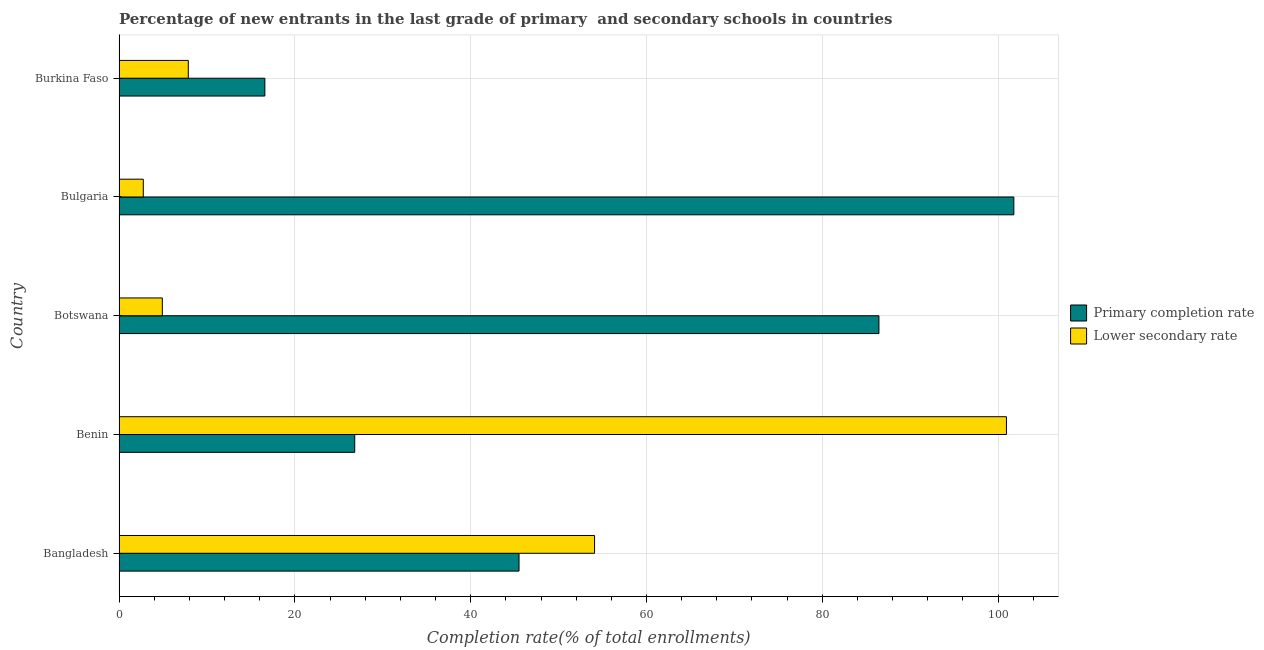How many different coloured bars are there?
Offer a terse response. 2. How many groups of bars are there?
Keep it short and to the point. 5. How many bars are there on the 2nd tick from the bottom?
Provide a succinct answer. 2. What is the completion rate in secondary schools in Botswana?
Offer a terse response. 4.92. Across all countries, what is the maximum completion rate in secondary schools?
Your response must be concise. 100.95. Across all countries, what is the minimum completion rate in primary schools?
Offer a terse response. 16.59. In which country was the completion rate in primary schools maximum?
Ensure brevity in your answer.  Bulgaria. In which country was the completion rate in secondary schools minimum?
Your answer should be very brief. Bulgaria. What is the total completion rate in secondary schools in the graph?
Give a very brief answer. 170.6. What is the difference between the completion rate in secondary schools in Benin and that in Bulgaria?
Provide a short and direct response. 98.19. What is the difference between the completion rate in primary schools in Botswana and the completion rate in secondary schools in Burkina Faso?
Offer a terse response. 78.57. What is the average completion rate in secondary schools per country?
Your response must be concise. 34.12. What is the difference between the completion rate in primary schools and completion rate in secondary schools in Botswana?
Give a very brief answer. 81.52. What is the ratio of the completion rate in primary schools in Bangladesh to that in Bulgaria?
Ensure brevity in your answer.  0.45. Is the completion rate in primary schools in Bangladesh less than that in Benin?
Provide a succinct answer. No. Is the difference between the completion rate in secondary schools in Bangladesh and Botswana greater than the difference between the completion rate in primary schools in Bangladesh and Botswana?
Offer a terse response. Yes. What is the difference between the highest and the second highest completion rate in primary schools?
Offer a terse response. 15.35. What is the difference between the highest and the lowest completion rate in secondary schools?
Ensure brevity in your answer.  98.19. Is the sum of the completion rate in primary schools in Bangladesh and Benin greater than the maximum completion rate in secondary schools across all countries?
Make the answer very short. No. What does the 2nd bar from the top in Botswana represents?
Offer a terse response. Primary completion rate. What does the 1st bar from the bottom in Bangladesh represents?
Your response must be concise. Primary completion rate. Are all the bars in the graph horizontal?
Offer a terse response. Yes. What is the difference between two consecutive major ticks on the X-axis?
Make the answer very short. 20. Are the values on the major ticks of X-axis written in scientific E-notation?
Offer a very short reply. No. Does the graph contain grids?
Provide a succinct answer. Yes. How many legend labels are there?
Keep it short and to the point. 2. How are the legend labels stacked?
Provide a succinct answer. Vertical. What is the title of the graph?
Your response must be concise. Percentage of new entrants in the last grade of primary  and secondary schools in countries. Does "Imports" appear as one of the legend labels in the graph?
Ensure brevity in your answer.  No. What is the label or title of the X-axis?
Your response must be concise. Completion rate(% of total enrollments). What is the label or title of the Y-axis?
Keep it short and to the point. Country. What is the Completion rate(% of total enrollments) of Primary completion rate in Bangladesh?
Give a very brief answer. 45.5. What is the Completion rate(% of total enrollments) in Lower secondary rate in Bangladesh?
Ensure brevity in your answer.  54.09. What is the Completion rate(% of total enrollments) of Primary completion rate in Benin?
Make the answer very short. 26.81. What is the Completion rate(% of total enrollments) of Lower secondary rate in Benin?
Give a very brief answer. 100.95. What is the Completion rate(% of total enrollments) of Primary completion rate in Botswana?
Provide a succinct answer. 86.44. What is the Completion rate(% of total enrollments) in Lower secondary rate in Botswana?
Provide a succinct answer. 4.92. What is the Completion rate(% of total enrollments) in Primary completion rate in Bulgaria?
Provide a short and direct response. 101.79. What is the Completion rate(% of total enrollments) in Lower secondary rate in Bulgaria?
Make the answer very short. 2.76. What is the Completion rate(% of total enrollments) in Primary completion rate in Burkina Faso?
Offer a terse response. 16.59. What is the Completion rate(% of total enrollments) of Lower secondary rate in Burkina Faso?
Make the answer very short. 7.88. Across all countries, what is the maximum Completion rate(% of total enrollments) of Primary completion rate?
Your answer should be compact. 101.79. Across all countries, what is the maximum Completion rate(% of total enrollments) in Lower secondary rate?
Your response must be concise. 100.95. Across all countries, what is the minimum Completion rate(% of total enrollments) in Primary completion rate?
Offer a very short reply. 16.59. Across all countries, what is the minimum Completion rate(% of total enrollments) of Lower secondary rate?
Give a very brief answer. 2.76. What is the total Completion rate(% of total enrollments) of Primary completion rate in the graph?
Provide a succinct answer. 277.13. What is the total Completion rate(% of total enrollments) in Lower secondary rate in the graph?
Give a very brief answer. 170.6. What is the difference between the Completion rate(% of total enrollments) of Primary completion rate in Bangladesh and that in Benin?
Provide a short and direct response. 18.69. What is the difference between the Completion rate(% of total enrollments) in Lower secondary rate in Bangladesh and that in Benin?
Provide a short and direct response. -46.85. What is the difference between the Completion rate(% of total enrollments) in Primary completion rate in Bangladesh and that in Botswana?
Offer a very short reply. -40.94. What is the difference between the Completion rate(% of total enrollments) of Lower secondary rate in Bangladesh and that in Botswana?
Your answer should be compact. 49.17. What is the difference between the Completion rate(% of total enrollments) of Primary completion rate in Bangladesh and that in Bulgaria?
Offer a very short reply. -56.29. What is the difference between the Completion rate(% of total enrollments) of Lower secondary rate in Bangladesh and that in Bulgaria?
Offer a very short reply. 51.33. What is the difference between the Completion rate(% of total enrollments) of Primary completion rate in Bangladesh and that in Burkina Faso?
Offer a very short reply. 28.91. What is the difference between the Completion rate(% of total enrollments) of Lower secondary rate in Bangladesh and that in Burkina Faso?
Your answer should be very brief. 46.22. What is the difference between the Completion rate(% of total enrollments) of Primary completion rate in Benin and that in Botswana?
Offer a terse response. -59.63. What is the difference between the Completion rate(% of total enrollments) of Lower secondary rate in Benin and that in Botswana?
Keep it short and to the point. 96.02. What is the difference between the Completion rate(% of total enrollments) of Primary completion rate in Benin and that in Bulgaria?
Your response must be concise. -74.98. What is the difference between the Completion rate(% of total enrollments) in Lower secondary rate in Benin and that in Bulgaria?
Make the answer very short. 98.19. What is the difference between the Completion rate(% of total enrollments) in Primary completion rate in Benin and that in Burkina Faso?
Your answer should be compact. 10.22. What is the difference between the Completion rate(% of total enrollments) of Lower secondary rate in Benin and that in Burkina Faso?
Provide a succinct answer. 93.07. What is the difference between the Completion rate(% of total enrollments) in Primary completion rate in Botswana and that in Bulgaria?
Ensure brevity in your answer.  -15.35. What is the difference between the Completion rate(% of total enrollments) of Lower secondary rate in Botswana and that in Bulgaria?
Make the answer very short. 2.16. What is the difference between the Completion rate(% of total enrollments) of Primary completion rate in Botswana and that in Burkina Faso?
Provide a short and direct response. 69.86. What is the difference between the Completion rate(% of total enrollments) of Lower secondary rate in Botswana and that in Burkina Faso?
Ensure brevity in your answer.  -2.95. What is the difference between the Completion rate(% of total enrollments) of Primary completion rate in Bulgaria and that in Burkina Faso?
Your answer should be very brief. 85.2. What is the difference between the Completion rate(% of total enrollments) of Lower secondary rate in Bulgaria and that in Burkina Faso?
Keep it short and to the point. -5.12. What is the difference between the Completion rate(% of total enrollments) in Primary completion rate in Bangladesh and the Completion rate(% of total enrollments) in Lower secondary rate in Benin?
Your response must be concise. -55.45. What is the difference between the Completion rate(% of total enrollments) in Primary completion rate in Bangladesh and the Completion rate(% of total enrollments) in Lower secondary rate in Botswana?
Make the answer very short. 40.58. What is the difference between the Completion rate(% of total enrollments) of Primary completion rate in Bangladesh and the Completion rate(% of total enrollments) of Lower secondary rate in Bulgaria?
Your answer should be very brief. 42.74. What is the difference between the Completion rate(% of total enrollments) in Primary completion rate in Bangladesh and the Completion rate(% of total enrollments) in Lower secondary rate in Burkina Faso?
Provide a short and direct response. 37.62. What is the difference between the Completion rate(% of total enrollments) in Primary completion rate in Benin and the Completion rate(% of total enrollments) in Lower secondary rate in Botswana?
Offer a very short reply. 21.89. What is the difference between the Completion rate(% of total enrollments) of Primary completion rate in Benin and the Completion rate(% of total enrollments) of Lower secondary rate in Bulgaria?
Offer a terse response. 24.05. What is the difference between the Completion rate(% of total enrollments) in Primary completion rate in Benin and the Completion rate(% of total enrollments) in Lower secondary rate in Burkina Faso?
Offer a very short reply. 18.93. What is the difference between the Completion rate(% of total enrollments) of Primary completion rate in Botswana and the Completion rate(% of total enrollments) of Lower secondary rate in Bulgaria?
Keep it short and to the point. 83.68. What is the difference between the Completion rate(% of total enrollments) in Primary completion rate in Botswana and the Completion rate(% of total enrollments) in Lower secondary rate in Burkina Faso?
Provide a succinct answer. 78.57. What is the difference between the Completion rate(% of total enrollments) in Primary completion rate in Bulgaria and the Completion rate(% of total enrollments) in Lower secondary rate in Burkina Faso?
Your answer should be very brief. 93.91. What is the average Completion rate(% of total enrollments) in Primary completion rate per country?
Your response must be concise. 55.43. What is the average Completion rate(% of total enrollments) in Lower secondary rate per country?
Provide a succinct answer. 34.12. What is the difference between the Completion rate(% of total enrollments) in Primary completion rate and Completion rate(% of total enrollments) in Lower secondary rate in Bangladesh?
Your response must be concise. -8.59. What is the difference between the Completion rate(% of total enrollments) in Primary completion rate and Completion rate(% of total enrollments) in Lower secondary rate in Benin?
Offer a very short reply. -74.14. What is the difference between the Completion rate(% of total enrollments) in Primary completion rate and Completion rate(% of total enrollments) in Lower secondary rate in Botswana?
Offer a terse response. 81.52. What is the difference between the Completion rate(% of total enrollments) in Primary completion rate and Completion rate(% of total enrollments) in Lower secondary rate in Bulgaria?
Keep it short and to the point. 99.03. What is the difference between the Completion rate(% of total enrollments) of Primary completion rate and Completion rate(% of total enrollments) of Lower secondary rate in Burkina Faso?
Your response must be concise. 8.71. What is the ratio of the Completion rate(% of total enrollments) in Primary completion rate in Bangladesh to that in Benin?
Provide a succinct answer. 1.7. What is the ratio of the Completion rate(% of total enrollments) of Lower secondary rate in Bangladesh to that in Benin?
Give a very brief answer. 0.54. What is the ratio of the Completion rate(% of total enrollments) of Primary completion rate in Bangladesh to that in Botswana?
Offer a terse response. 0.53. What is the ratio of the Completion rate(% of total enrollments) of Lower secondary rate in Bangladesh to that in Botswana?
Offer a very short reply. 10.99. What is the ratio of the Completion rate(% of total enrollments) in Primary completion rate in Bangladesh to that in Bulgaria?
Make the answer very short. 0.45. What is the ratio of the Completion rate(% of total enrollments) in Lower secondary rate in Bangladesh to that in Bulgaria?
Give a very brief answer. 19.61. What is the ratio of the Completion rate(% of total enrollments) in Primary completion rate in Bangladesh to that in Burkina Faso?
Offer a terse response. 2.74. What is the ratio of the Completion rate(% of total enrollments) in Lower secondary rate in Bangladesh to that in Burkina Faso?
Give a very brief answer. 6.87. What is the ratio of the Completion rate(% of total enrollments) in Primary completion rate in Benin to that in Botswana?
Offer a terse response. 0.31. What is the ratio of the Completion rate(% of total enrollments) of Lower secondary rate in Benin to that in Botswana?
Your answer should be compact. 20.51. What is the ratio of the Completion rate(% of total enrollments) in Primary completion rate in Benin to that in Bulgaria?
Keep it short and to the point. 0.26. What is the ratio of the Completion rate(% of total enrollments) in Lower secondary rate in Benin to that in Bulgaria?
Make the answer very short. 36.6. What is the ratio of the Completion rate(% of total enrollments) in Primary completion rate in Benin to that in Burkina Faso?
Offer a very short reply. 1.62. What is the ratio of the Completion rate(% of total enrollments) in Lower secondary rate in Benin to that in Burkina Faso?
Your response must be concise. 12.82. What is the ratio of the Completion rate(% of total enrollments) of Primary completion rate in Botswana to that in Bulgaria?
Your answer should be compact. 0.85. What is the ratio of the Completion rate(% of total enrollments) in Lower secondary rate in Botswana to that in Bulgaria?
Provide a succinct answer. 1.78. What is the ratio of the Completion rate(% of total enrollments) of Primary completion rate in Botswana to that in Burkina Faso?
Your response must be concise. 5.21. What is the ratio of the Completion rate(% of total enrollments) of Lower secondary rate in Botswana to that in Burkina Faso?
Keep it short and to the point. 0.62. What is the ratio of the Completion rate(% of total enrollments) of Primary completion rate in Bulgaria to that in Burkina Faso?
Make the answer very short. 6.14. What is the ratio of the Completion rate(% of total enrollments) of Lower secondary rate in Bulgaria to that in Burkina Faso?
Offer a terse response. 0.35. What is the difference between the highest and the second highest Completion rate(% of total enrollments) in Primary completion rate?
Provide a short and direct response. 15.35. What is the difference between the highest and the second highest Completion rate(% of total enrollments) of Lower secondary rate?
Your answer should be compact. 46.85. What is the difference between the highest and the lowest Completion rate(% of total enrollments) of Primary completion rate?
Provide a short and direct response. 85.2. What is the difference between the highest and the lowest Completion rate(% of total enrollments) in Lower secondary rate?
Your answer should be compact. 98.19. 